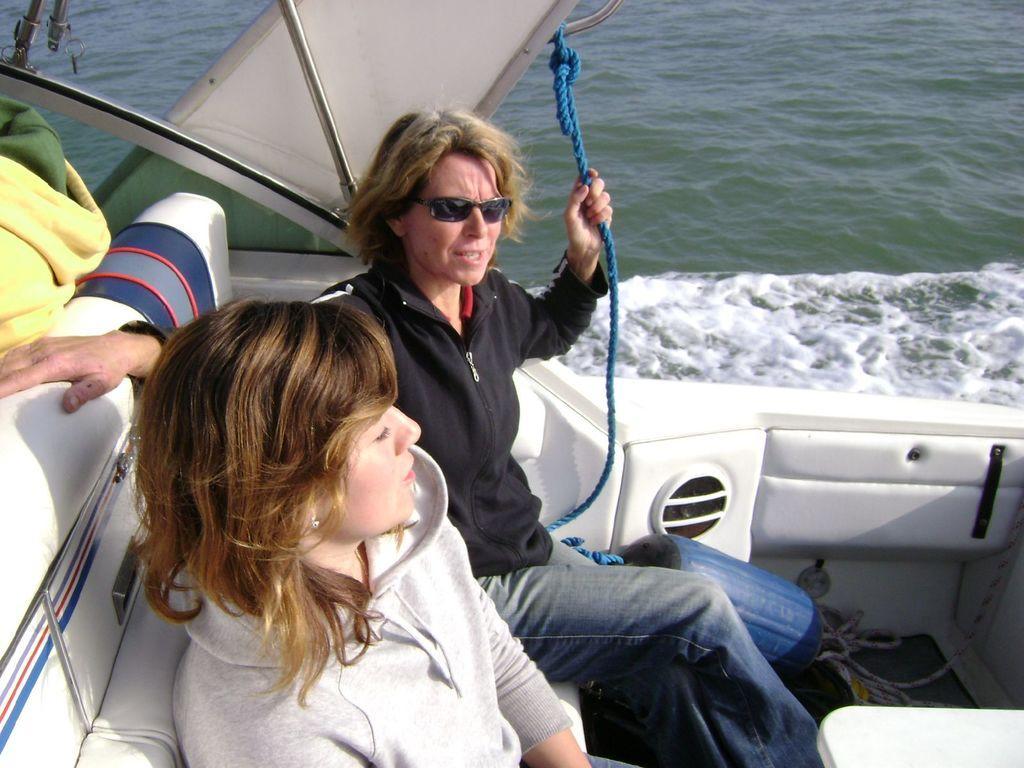Please provide a concise description of this image. In this picture I can observe two women sitting in the boat. One of them is wearing spectacles. In the background I can observe water. 